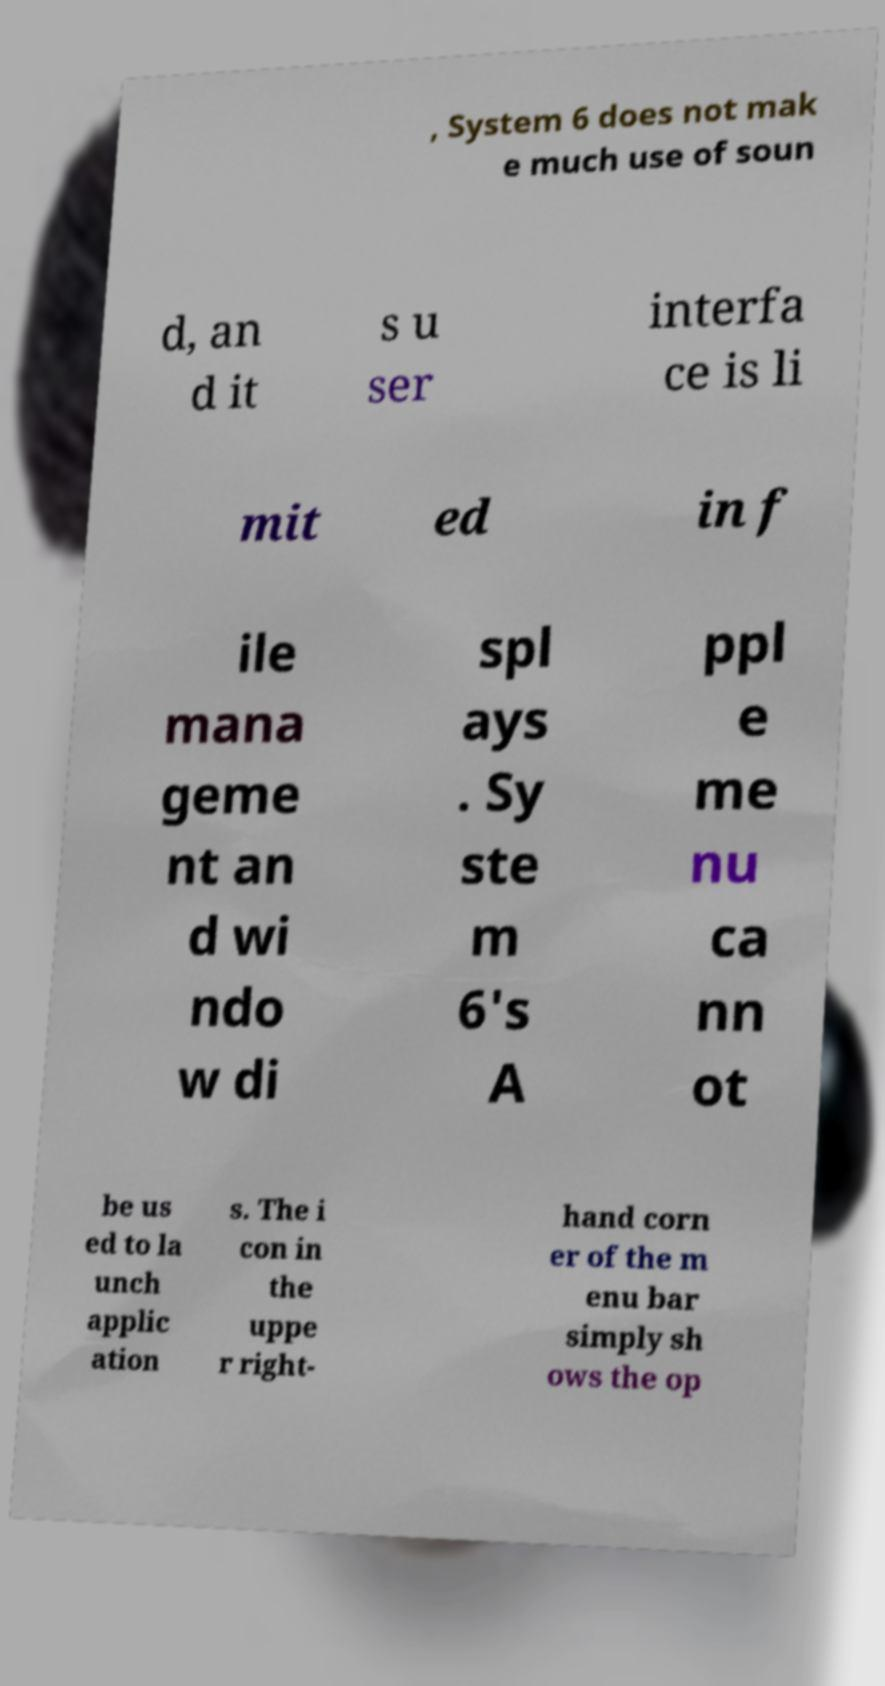Could you extract and type out the text from this image? , System 6 does not mak e much use of soun d, an d it s u ser interfa ce is li mit ed in f ile mana geme nt an d wi ndo w di spl ays . Sy ste m 6's A ppl e me nu ca nn ot be us ed to la unch applic ation s. The i con in the uppe r right- hand corn er of the m enu bar simply sh ows the op 